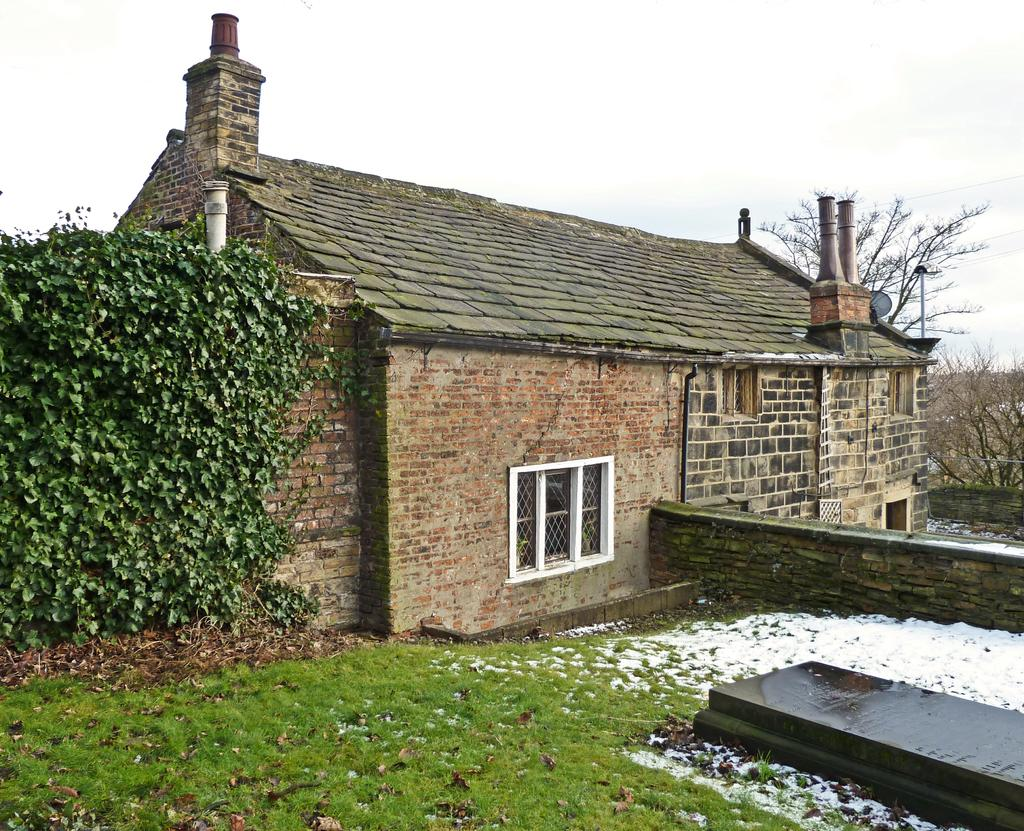What type of building is in the image? There is a home in the image. What is in front of the home? Grass is present in front of the home. What is on either side of the home? There are plants on either side of the home. What can be seen above the home? The sky is visible above the home. What type of structure is being exchanged between the two people in the image? There are no people present in the image, and therefore no structure is being exchanged. 